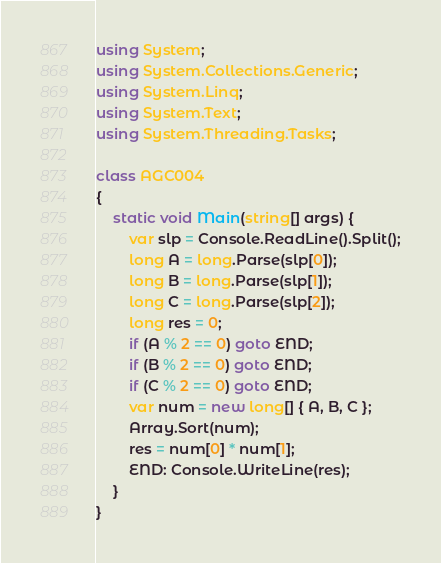<code> <loc_0><loc_0><loc_500><loc_500><_C#_>using System;
using System.Collections.Generic;
using System.Linq;
using System.Text;
using System.Threading.Tasks;

class AGC004
{
    static void Main(string[] args) {
        var slp = Console.ReadLine().Split();
        long A = long.Parse(slp[0]);
        long B = long.Parse(slp[1]);
        long C = long.Parse(slp[2]);
        long res = 0;
        if (A % 2 == 0) goto END;
        if (B % 2 == 0) goto END;
        if (C % 2 == 0) goto END;
        var num = new long[] { A, B, C };
        Array.Sort(num);
        res = num[0] * num[1];
        END: Console.WriteLine(res);
    }
}
</code> 